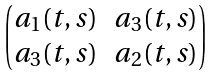Convert formula to latex. <formula><loc_0><loc_0><loc_500><loc_500>\begin{pmatrix} a _ { 1 } ( t , s ) & a _ { 3 } ( t , s ) \\ a _ { 3 } ( t , s ) & a _ { 2 } ( t , s ) \end{pmatrix}</formula> 